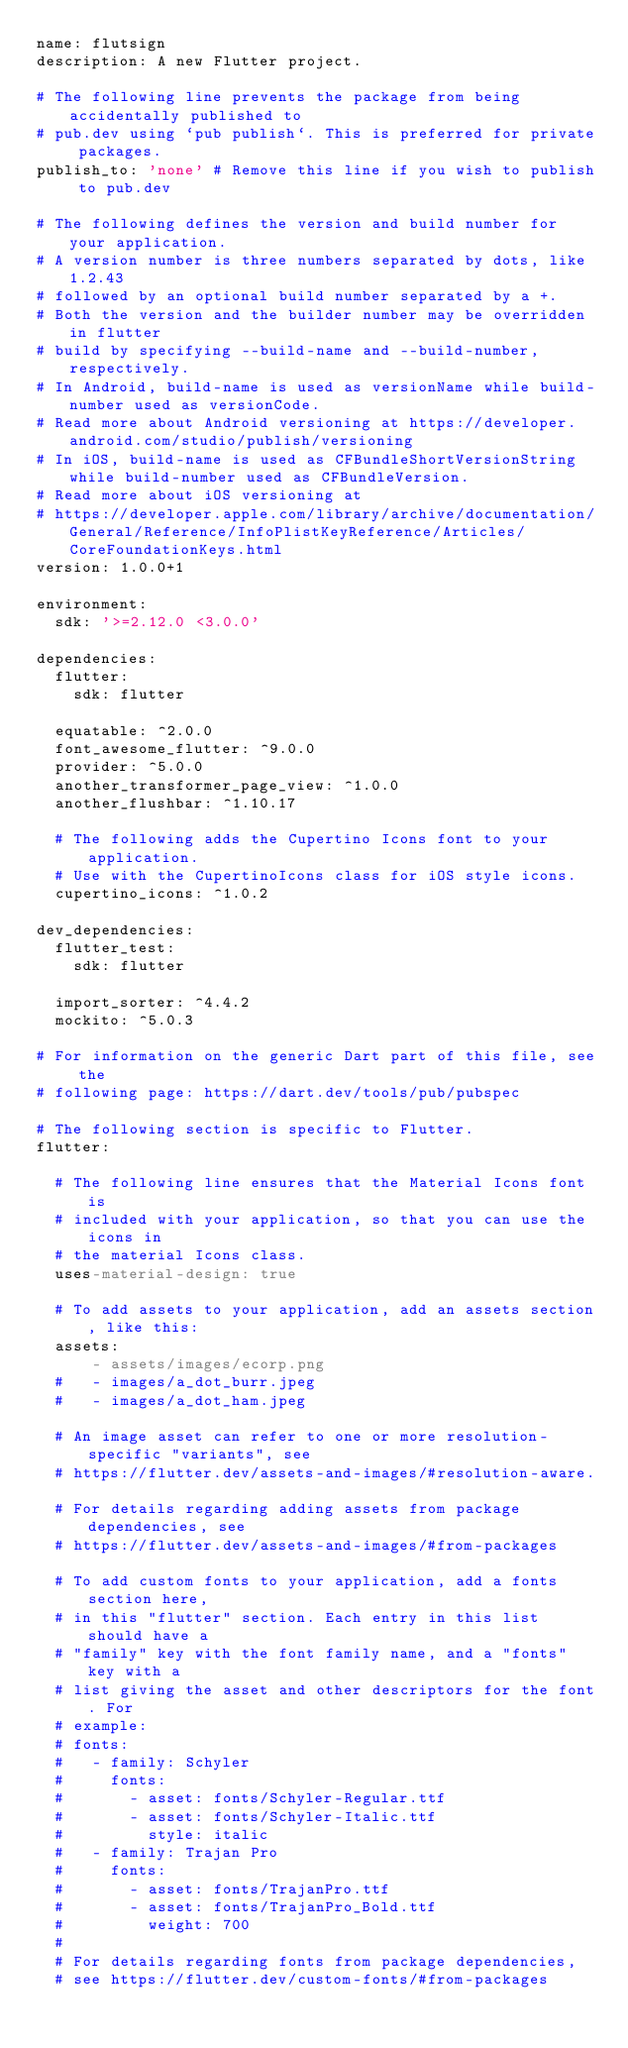Convert code to text. <code><loc_0><loc_0><loc_500><loc_500><_YAML_>name: flutsign
description: A new Flutter project.

# The following line prevents the package from being accidentally published to
# pub.dev using `pub publish`. This is preferred for private packages.
publish_to: 'none' # Remove this line if you wish to publish to pub.dev

# The following defines the version and build number for your application.
# A version number is three numbers separated by dots, like 1.2.43
# followed by an optional build number separated by a +.
# Both the version and the builder number may be overridden in flutter
# build by specifying --build-name and --build-number, respectively.
# In Android, build-name is used as versionName while build-number used as versionCode.
# Read more about Android versioning at https://developer.android.com/studio/publish/versioning
# In iOS, build-name is used as CFBundleShortVersionString while build-number used as CFBundleVersion.
# Read more about iOS versioning at
# https://developer.apple.com/library/archive/documentation/General/Reference/InfoPlistKeyReference/Articles/CoreFoundationKeys.html
version: 1.0.0+1

environment:
  sdk: '>=2.12.0 <3.0.0'

dependencies:
  flutter:
    sdk: flutter

  equatable: ^2.0.0
  font_awesome_flutter: ^9.0.0
  provider: ^5.0.0
  another_transformer_page_view: ^1.0.0
  another_flushbar: ^1.10.17

  # The following adds the Cupertino Icons font to your application.
  # Use with the CupertinoIcons class for iOS style icons.
  cupertino_icons: ^1.0.2

dev_dependencies:
  flutter_test:
    sdk: flutter
  
  import_sorter: ^4.4.2
  mockito: ^5.0.3

# For information on the generic Dart part of this file, see the
# following page: https://dart.dev/tools/pub/pubspec

# The following section is specific to Flutter.
flutter:

  # The following line ensures that the Material Icons font is
  # included with your application, so that you can use the icons in
  # the material Icons class.
  uses-material-design: true

  # To add assets to your application, add an assets section, like this:
  assets:
      - assets/images/ecorp.png
  #   - images/a_dot_burr.jpeg
  #   - images/a_dot_ham.jpeg

  # An image asset can refer to one or more resolution-specific "variants", see
  # https://flutter.dev/assets-and-images/#resolution-aware.

  # For details regarding adding assets from package dependencies, see
  # https://flutter.dev/assets-and-images/#from-packages

  # To add custom fonts to your application, add a fonts section here,
  # in this "flutter" section. Each entry in this list should have a
  # "family" key with the font family name, and a "fonts" key with a
  # list giving the asset and other descriptors for the font. For
  # example:
  # fonts:
  #   - family: Schyler
  #     fonts:
  #       - asset: fonts/Schyler-Regular.ttf
  #       - asset: fonts/Schyler-Italic.ttf
  #         style: italic
  #   - family: Trajan Pro
  #     fonts:
  #       - asset: fonts/TrajanPro.ttf
  #       - asset: fonts/TrajanPro_Bold.ttf
  #         weight: 700
  #
  # For details regarding fonts from package dependencies,
  # see https://flutter.dev/custom-fonts/#from-packages
</code> 